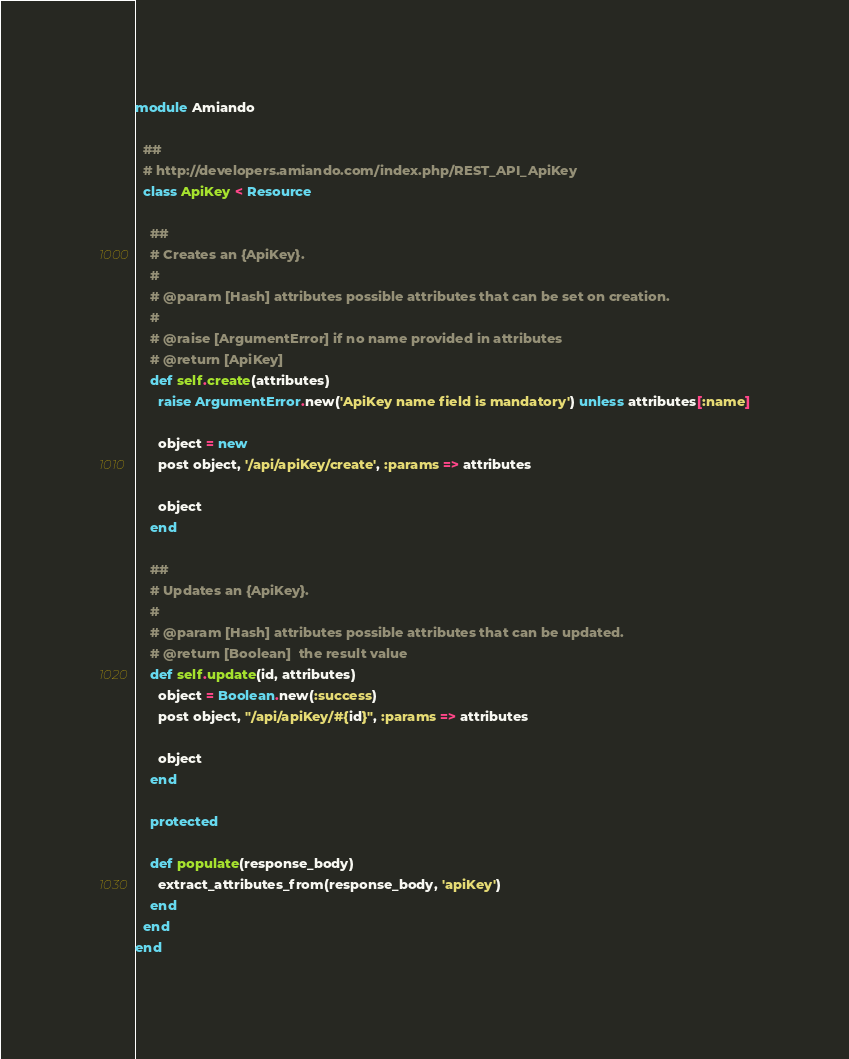Convert code to text. <code><loc_0><loc_0><loc_500><loc_500><_Ruby_>module Amiando

  ##
  # http://developers.amiando.com/index.php/REST_API_ApiKey
  class ApiKey < Resource

    ##
    # Creates an {ApiKey}.
    #
    # @param [Hash] attributes possible attributes that can be set on creation.
    #
    # @raise [ArgumentError] if no name provided in attributes
    # @return [ApiKey]
    def self.create(attributes)
      raise ArgumentError.new('ApiKey name field is mandatory') unless attributes[:name]

      object = new
      post object, '/api/apiKey/create', :params => attributes

      object
    end

    ##
    # Updates an {ApiKey}.
    #
    # @param [Hash] attributes possible attributes that can be updated.
    # @return [Boolean]  the result value
    def self.update(id, attributes)
      object = Boolean.new(:success)
      post object, "/api/apiKey/#{id}", :params => attributes

      object
    end

    protected

    def populate(response_body)
      extract_attributes_from(response_body, 'apiKey')
    end
  end
end
</code> 